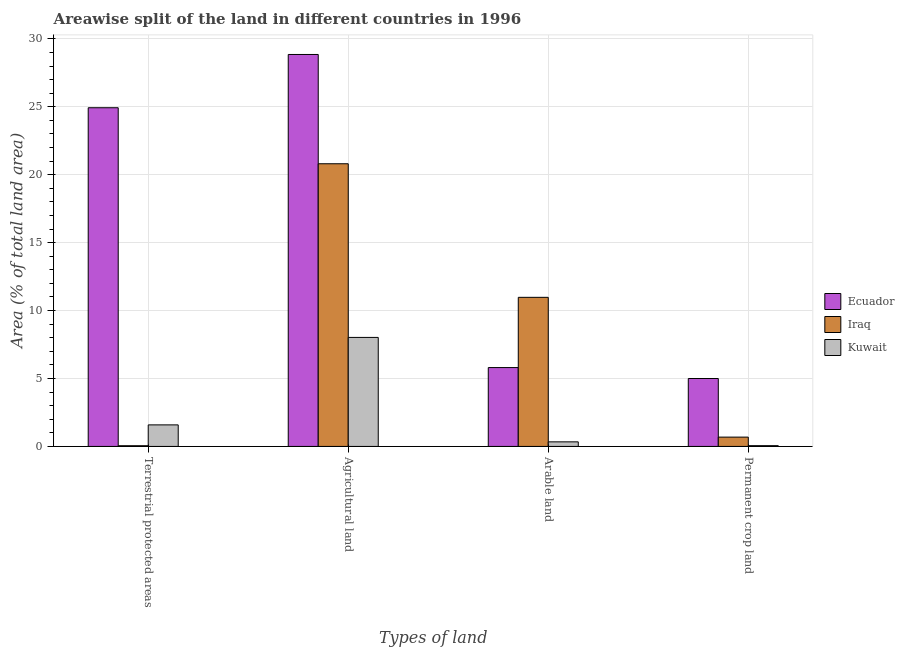How many different coloured bars are there?
Ensure brevity in your answer.  3. How many bars are there on the 2nd tick from the left?
Your answer should be very brief. 3. How many bars are there on the 2nd tick from the right?
Provide a short and direct response. 3. What is the label of the 4th group of bars from the left?
Provide a short and direct response. Permanent crop land. What is the percentage of area under agricultural land in Iraq?
Ensure brevity in your answer.  20.81. Across all countries, what is the maximum percentage of area under permanent crop land?
Your response must be concise. 5. Across all countries, what is the minimum percentage of area under permanent crop land?
Offer a terse response. 0.06. In which country was the percentage of area under permanent crop land maximum?
Make the answer very short. Ecuador. In which country was the percentage of area under permanent crop land minimum?
Your answer should be very brief. Kuwait. What is the total percentage of land under terrestrial protection in the graph?
Give a very brief answer. 26.57. What is the difference between the percentage of area under arable land in Ecuador and that in Kuwait?
Provide a succinct answer. 5.47. What is the difference between the percentage of area under arable land in Ecuador and the percentage of land under terrestrial protection in Kuwait?
Provide a succinct answer. 4.22. What is the average percentage of area under arable land per country?
Offer a very short reply. 5.71. What is the difference between the percentage of land under terrestrial protection and percentage of area under permanent crop land in Ecuador?
Keep it short and to the point. 19.93. In how many countries, is the percentage of area under arable land greater than 6 %?
Offer a very short reply. 1. What is the ratio of the percentage of area under agricultural land in Ecuador to that in Iraq?
Your answer should be compact. 1.39. What is the difference between the highest and the second highest percentage of area under arable land?
Give a very brief answer. 5.17. What is the difference between the highest and the lowest percentage of area under agricultural land?
Provide a short and direct response. 20.83. In how many countries, is the percentage of area under permanent crop land greater than the average percentage of area under permanent crop land taken over all countries?
Offer a very short reply. 1. Is the sum of the percentage of land under terrestrial protection in Kuwait and Ecuador greater than the maximum percentage of area under agricultural land across all countries?
Make the answer very short. No. What does the 2nd bar from the left in Terrestrial protected areas represents?
Provide a succinct answer. Iraq. What does the 2nd bar from the right in Arable land represents?
Offer a terse response. Iraq. Is it the case that in every country, the sum of the percentage of land under terrestrial protection and percentage of area under agricultural land is greater than the percentage of area under arable land?
Your answer should be compact. Yes. How many bars are there?
Provide a short and direct response. 12. What is the difference between two consecutive major ticks on the Y-axis?
Your response must be concise. 5. Are the values on the major ticks of Y-axis written in scientific E-notation?
Your response must be concise. No. Does the graph contain any zero values?
Your answer should be compact. No. How are the legend labels stacked?
Keep it short and to the point. Vertical. What is the title of the graph?
Your response must be concise. Areawise split of the land in different countries in 1996. Does "Mauritius" appear as one of the legend labels in the graph?
Your response must be concise. No. What is the label or title of the X-axis?
Your answer should be compact. Types of land. What is the label or title of the Y-axis?
Make the answer very short. Area (% of total land area). What is the Area (% of total land area) in Ecuador in Terrestrial protected areas?
Offer a very short reply. 24.93. What is the Area (% of total land area) of Iraq in Terrestrial protected areas?
Provide a succinct answer. 0.05. What is the Area (% of total land area) in Kuwait in Terrestrial protected areas?
Provide a short and direct response. 1.59. What is the Area (% of total land area) in Ecuador in Agricultural land?
Provide a short and direct response. 28.85. What is the Area (% of total land area) in Iraq in Agricultural land?
Give a very brief answer. 20.81. What is the Area (% of total land area) of Kuwait in Agricultural land?
Make the answer very short. 8.02. What is the Area (% of total land area) in Ecuador in Arable land?
Give a very brief answer. 5.8. What is the Area (% of total land area) in Iraq in Arable land?
Make the answer very short. 10.97. What is the Area (% of total land area) in Kuwait in Arable land?
Provide a succinct answer. 0.34. What is the Area (% of total land area) in Ecuador in Permanent crop land?
Your response must be concise. 5. What is the Area (% of total land area) in Iraq in Permanent crop land?
Keep it short and to the point. 0.69. What is the Area (% of total land area) in Kuwait in Permanent crop land?
Keep it short and to the point. 0.06. Across all Types of land, what is the maximum Area (% of total land area) of Ecuador?
Your response must be concise. 28.85. Across all Types of land, what is the maximum Area (% of total land area) of Iraq?
Give a very brief answer. 20.81. Across all Types of land, what is the maximum Area (% of total land area) in Kuwait?
Your answer should be very brief. 8.02. Across all Types of land, what is the minimum Area (% of total land area) of Ecuador?
Offer a terse response. 5. Across all Types of land, what is the minimum Area (% of total land area) of Iraq?
Your response must be concise. 0.05. Across all Types of land, what is the minimum Area (% of total land area) in Kuwait?
Ensure brevity in your answer.  0.06. What is the total Area (% of total land area) in Ecuador in the graph?
Your response must be concise. 64.58. What is the total Area (% of total land area) of Iraq in the graph?
Your answer should be compact. 32.52. What is the total Area (% of total land area) in Kuwait in the graph?
Keep it short and to the point. 10. What is the difference between the Area (% of total land area) in Ecuador in Terrestrial protected areas and that in Agricultural land?
Your answer should be very brief. -3.92. What is the difference between the Area (% of total land area) in Iraq in Terrestrial protected areas and that in Agricultural land?
Ensure brevity in your answer.  -20.75. What is the difference between the Area (% of total land area) in Kuwait in Terrestrial protected areas and that in Agricultural land?
Make the answer very short. -6.44. What is the difference between the Area (% of total land area) of Ecuador in Terrestrial protected areas and that in Arable land?
Your answer should be compact. 19.12. What is the difference between the Area (% of total land area) of Iraq in Terrestrial protected areas and that in Arable land?
Keep it short and to the point. -10.92. What is the difference between the Area (% of total land area) in Kuwait in Terrestrial protected areas and that in Arable land?
Keep it short and to the point. 1.25. What is the difference between the Area (% of total land area) in Ecuador in Terrestrial protected areas and that in Permanent crop land?
Ensure brevity in your answer.  19.93. What is the difference between the Area (% of total land area) in Iraq in Terrestrial protected areas and that in Permanent crop land?
Make the answer very short. -0.63. What is the difference between the Area (% of total land area) in Kuwait in Terrestrial protected areas and that in Permanent crop land?
Your response must be concise. 1.53. What is the difference between the Area (% of total land area) of Ecuador in Agricultural land and that in Arable land?
Keep it short and to the point. 23.05. What is the difference between the Area (% of total land area) in Iraq in Agricultural land and that in Arable land?
Keep it short and to the point. 9.83. What is the difference between the Area (% of total land area) in Kuwait in Agricultural land and that in Arable land?
Your answer should be very brief. 7.69. What is the difference between the Area (% of total land area) of Ecuador in Agricultural land and that in Permanent crop land?
Your answer should be compact. 23.85. What is the difference between the Area (% of total land area) in Iraq in Agricultural land and that in Permanent crop land?
Offer a terse response. 20.12. What is the difference between the Area (% of total land area) in Kuwait in Agricultural land and that in Permanent crop land?
Keep it short and to the point. 7.97. What is the difference between the Area (% of total land area) of Ecuador in Arable land and that in Permanent crop land?
Your answer should be very brief. 0.81. What is the difference between the Area (% of total land area) of Iraq in Arable land and that in Permanent crop land?
Provide a short and direct response. 10.29. What is the difference between the Area (% of total land area) of Kuwait in Arable land and that in Permanent crop land?
Provide a succinct answer. 0.28. What is the difference between the Area (% of total land area) of Ecuador in Terrestrial protected areas and the Area (% of total land area) of Iraq in Agricultural land?
Offer a terse response. 4.12. What is the difference between the Area (% of total land area) of Ecuador in Terrestrial protected areas and the Area (% of total land area) of Kuwait in Agricultural land?
Your answer should be very brief. 16.91. What is the difference between the Area (% of total land area) in Iraq in Terrestrial protected areas and the Area (% of total land area) in Kuwait in Agricultural land?
Your answer should be compact. -7.97. What is the difference between the Area (% of total land area) of Ecuador in Terrestrial protected areas and the Area (% of total land area) of Iraq in Arable land?
Your answer should be very brief. 13.96. What is the difference between the Area (% of total land area) in Ecuador in Terrestrial protected areas and the Area (% of total land area) in Kuwait in Arable land?
Your answer should be compact. 24.59. What is the difference between the Area (% of total land area) in Iraq in Terrestrial protected areas and the Area (% of total land area) in Kuwait in Arable land?
Keep it short and to the point. -0.29. What is the difference between the Area (% of total land area) in Ecuador in Terrestrial protected areas and the Area (% of total land area) in Iraq in Permanent crop land?
Provide a short and direct response. 24.24. What is the difference between the Area (% of total land area) of Ecuador in Terrestrial protected areas and the Area (% of total land area) of Kuwait in Permanent crop land?
Provide a short and direct response. 24.87. What is the difference between the Area (% of total land area) of Iraq in Terrestrial protected areas and the Area (% of total land area) of Kuwait in Permanent crop land?
Offer a terse response. -0.01. What is the difference between the Area (% of total land area) in Ecuador in Agricultural land and the Area (% of total land area) in Iraq in Arable land?
Provide a succinct answer. 17.88. What is the difference between the Area (% of total land area) in Ecuador in Agricultural land and the Area (% of total land area) in Kuwait in Arable land?
Provide a succinct answer. 28.51. What is the difference between the Area (% of total land area) in Iraq in Agricultural land and the Area (% of total land area) in Kuwait in Arable land?
Your answer should be compact. 20.47. What is the difference between the Area (% of total land area) in Ecuador in Agricultural land and the Area (% of total land area) in Iraq in Permanent crop land?
Make the answer very short. 28.16. What is the difference between the Area (% of total land area) in Ecuador in Agricultural land and the Area (% of total land area) in Kuwait in Permanent crop land?
Offer a very short reply. 28.79. What is the difference between the Area (% of total land area) of Iraq in Agricultural land and the Area (% of total land area) of Kuwait in Permanent crop land?
Your response must be concise. 20.75. What is the difference between the Area (% of total land area) in Ecuador in Arable land and the Area (% of total land area) in Iraq in Permanent crop land?
Offer a very short reply. 5.12. What is the difference between the Area (% of total land area) in Ecuador in Arable land and the Area (% of total land area) in Kuwait in Permanent crop land?
Offer a very short reply. 5.75. What is the difference between the Area (% of total land area) in Iraq in Arable land and the Area (% of total land area) in Kuwait in Permanent crop land?
Your answer should be very brief. 10.92. What is the average Area (% of total land area) in Ecuador per Types of land?
Keep it short and to the point. 16.15. What is the average Area (% of total land area) of Iraq per Types of land?
Provide a succinct answer. 8.13. What is the average Area (% of total land area) of Kuwait per Types of land?
Make the answer very short. 2.5. What is the difference between the Area (% of total land area) in Ecuador and Area (% of total land area) in Iraq in Terrestrial protected areas?
Your answer should be compact. 24.88. What is the difference between the Area (% of total land area) in Ecuador and Area (% of total land area) in Kuwait in Terrestrial protected areas?
Offer a very short reply. 23.34. What is the difference between the Area (% of total land area) of Iraq and Area (% of total land area) of Kuwait in Terrestrial protected areas?
Offer a very short reply. -1.54. What is the difference between the Area (% of total land area) in Ecuador and Area (% of total land area) in Iraq in Agricultural land?
Make the answer very short. 8.04. What is the difference between the Area (% of total land area) of Ecuador and Area (% of total land area) of Kuwait in Agricultural land?
Provide a short and direct response. 20.83. What is the difference between the Area (% of total land area) of Iraq and Area (% of total land area) of Kuwait in Agricultural land?
Your answer should be compact. 12.78. What is the difference between the Area (% of total land area) of Ecuador and Area (% of total land area) of Iraq in Arable land?
Provide a short and direct response. -5.17. What is the difference between the Area (% of total land area) of Ecuador and Area (% of total land area) of Kuwait in Arable land?
Provide a succinct answer. 5.47. What is the difference between the Area (% of total land area) of Iraq and Area (% of total land area) of Kuwait in Arable land?
Keep it short and to the point. 10.64. What is the difference between the Area (% of total land area) of Ecuador and Area (% of total land area) of Iraq in Permanent crop land?
Your answer should be compact. 4.31. What is the difference between the Area (% of total land area) of Ecuador and Area (% of total land area) of Kuwait in Permanent crop land?
Your response must be concise. 4.94. What is the difference between the Area (% of total land area) of Iraq and Area (% of total land area) of Kuwait in Permanent crop land?
Offer a terse response. 0.63. What is the ratio of the Area (% of total land area) of Ecuador in Terrestrial protected areas to that in Agricultural land?
Provide a succinct answer. 0.86. What is the ratio of the Area (% of total land area) in Iraq in Terrestrial protected areas to that in Agricultural land?
Offer a very short reply. 0. What is the ratio of the Area (% of total land area) of Kuwait in Terrestrial protected areas to that in Agricultural land?
Your answer should be very brief. 0.2. What is the ratio of the Area (% of total land area) in Ecuador in Terrestrial protected areas to that in Arable land?
Your response must be concise. 4.29. What is the ratio of the Area (% of total land area) of Iraq in Terrestrial protected areas to that in Arable land?
Offer a terse response. 0. What is the ratio of the Area (% of total land area) in Kuwait in Terrestrial protected areas to that in Arable land?
Your answer should be compact. 4.71. What is the ratio of the Area (% of total land area) in Ecuador in Terrestrial protected areas to that in Permanent crop land?
Keep it short and to the point. 4.99. What is the ratio of the Area (% of total land area) in Iraq in Terrestrial protected areas to that in Permanent crop land?
Provide a short and direct response. 0.07. What is the ratio of the Area (% of total land area) of Kuwait in Terrestrial protected areas to that in Permanent crop land?
Your answer should be compact. 28.27. What is the ratio of the Area (% of total land area) in Ecuador in Agricultural land to that in Arable land?
Offer a very short reply. 4.97. What is the ratio of the Area (% of total land area) of Iraq in Agricultural land to that in Arable land?
Keep it short and to the point. 1.9. What is the ratio of the Area (% of total land area) of Kuwait in Agricultural land to that in Arable land?
Offer a very short reply. 23.83. What is the ratio of the Area (% of total land area) in Ecuador in Agricultural land to that in Permanent crop land?
Offer a terse response. 5.77. What is the ratio of the Area (% of total land area) in Iraq in Agricultural land to that in Permanent crop land?
Offer a terse response. 30.33. What is the ratio of the Area (% of total land area) in Kuwait in Agricultural land to that in Permanent crop land?
Provide a short and direct response. 143. What is the ratio of the Area (% of total land area) of Ecuador in Arable land to that in Permanent crop land?
Give a very brief answer. 1.16. What is the ratio of the Area (% of total land area) of Iraq in Arable land to that in Permanent crop land?
Keep it short and to the point. 16. What is the ratio of the Area (% of total land area) in Kuwait in Arable land to that in Permanent crop land?
Your answer should be compact. 6. What is the difference between the highest and the second highest Area (% of total land area) in Ecuador?
Your answer should be very brief. 3.92. What is the difference between the highest and the second highest Area (% of total land area) of Iraq?
Offer a terse response. 9.83. What is the difference between the highest and the second highest Area (% of total land area) of Kuwait?
Ensure brevity in your answer.  6.44. What is the difference between the highest and the lowest Area (% of total land area) of Ecuador?
Provide a succinct answer. 23.85. What is the difference between the highest and the lowest Area (% of total land area) of Iraq?
Offer a terse response. 20.75. What is the difference between the highest and the lowest Area (% of total land area) in Kuwait?
Your answer should be very brief. 7.97. 